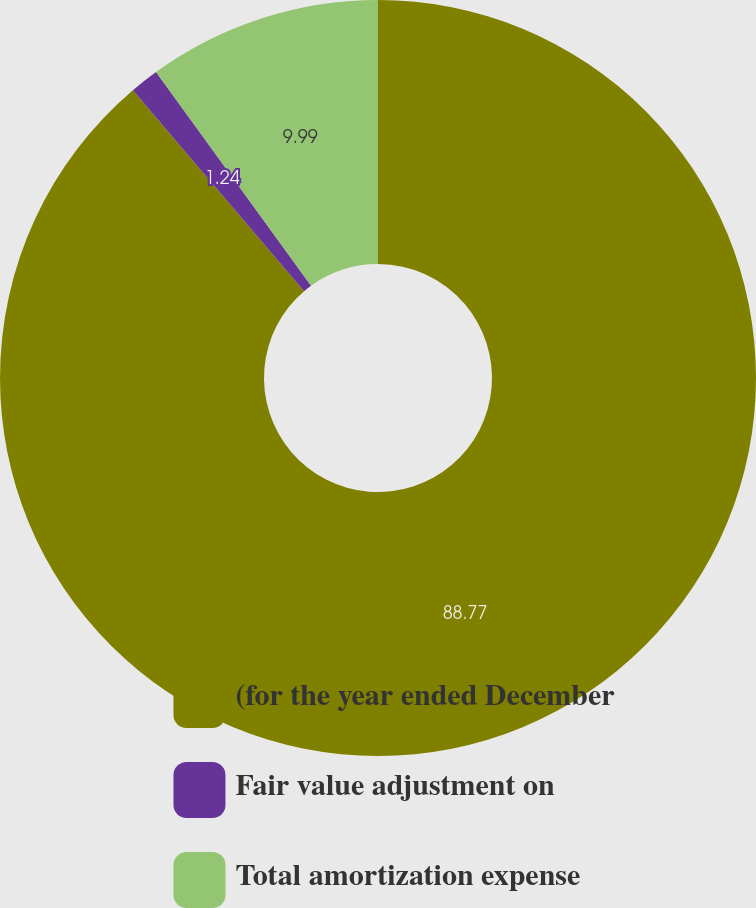Convert chart to OTSL. <chart><loc_0><loc_0><loc_500><loc_500><pie_chart><fcel>(for the year ended December<fcel>Fair value adjustment on<fcel>Total amortization expense<nl><fcel>88.77%<fcel>1.24%<fcel>9.99%<nl></chart> 